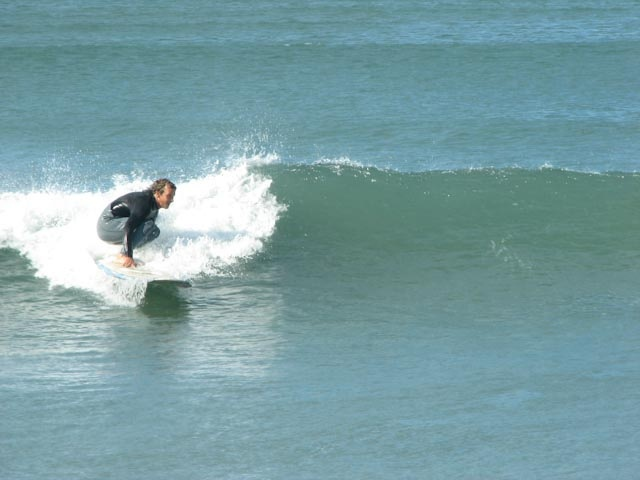Describe the objects in this image and their specific colors. I can see people in teal, gray, black, darkgray, and white tones and surfboard in teal, white, and darkgray tones in this image. 